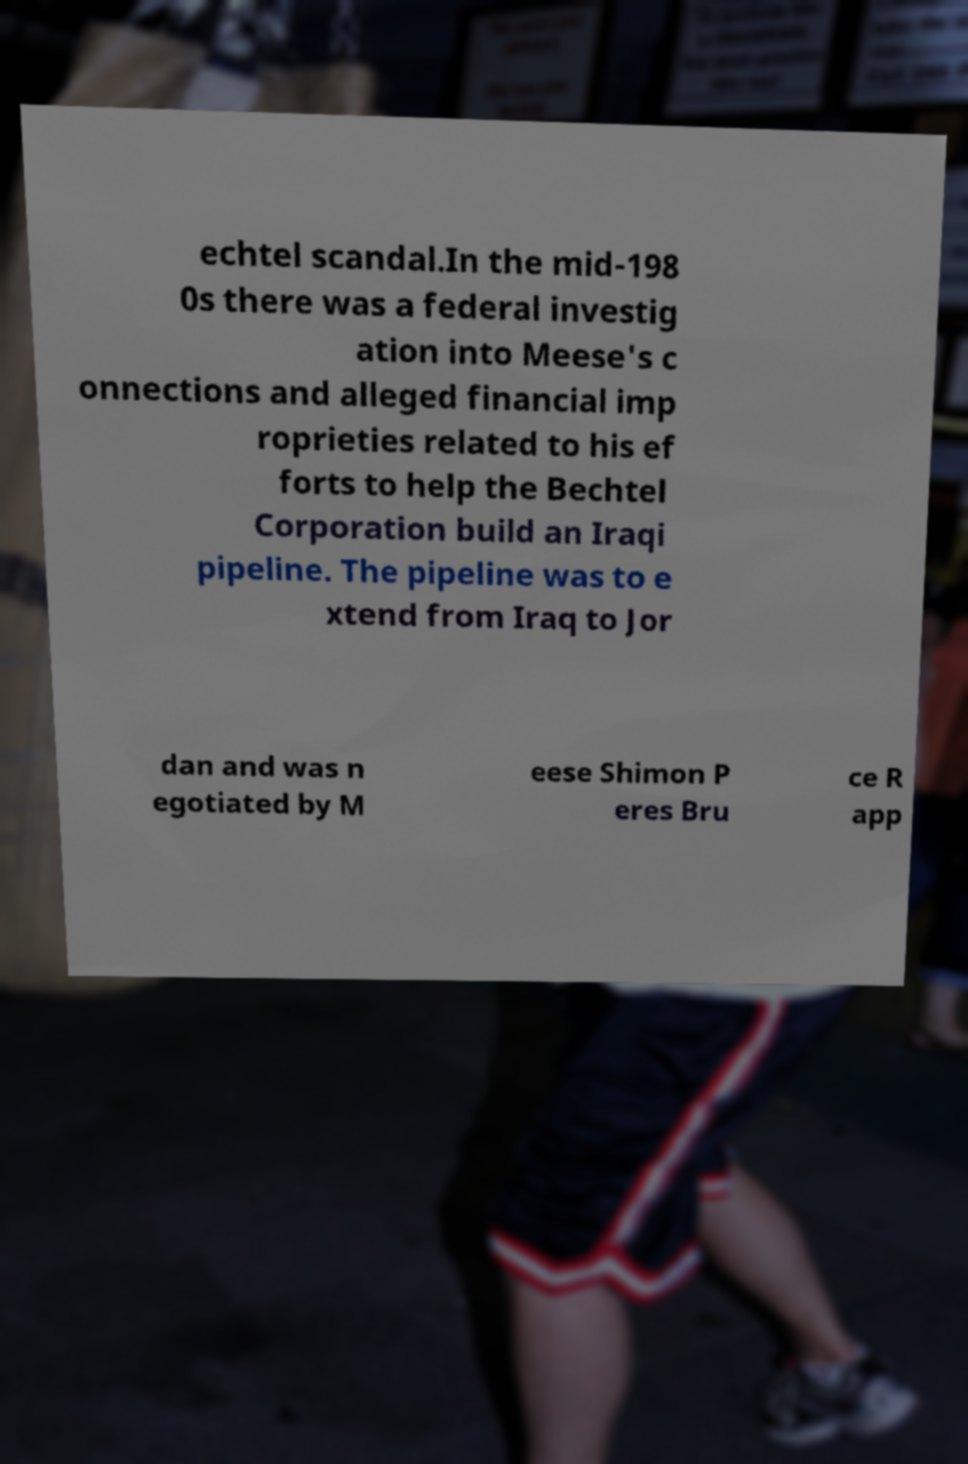Could you extract and type out the text from this image? echtel scandal.In the mid-198 0s there was a federal investig ation into Meese's c onnections and alleged financial imp roprieties related to his ef forts to help the Bechtel Corporation build an Iraqi pipeline. The pipeline was to e xtend from Iraq to Jor dan and was n egotiated by M eese Shimon P eres Bru ce R app 